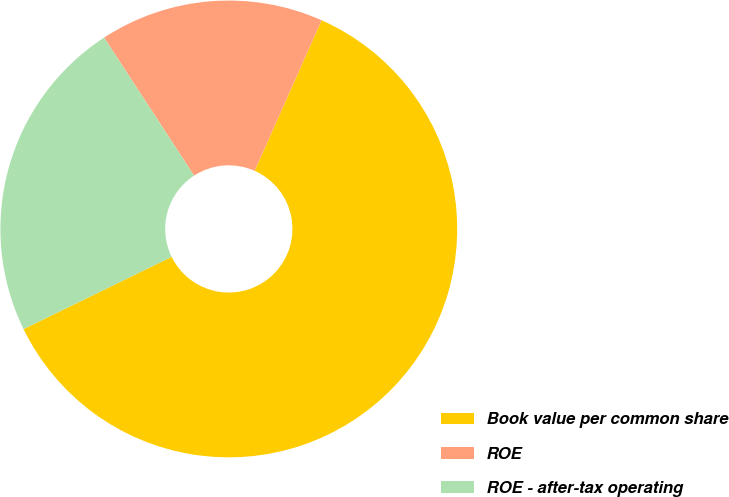Convert chart to OTSL. <chart><loc_0><loc_0><loc_500><loc_500><pie_chart><fcel>Book value per common share<fcel>ROE<fcel>ROE - after-tax operating<nl><fcel>61.12%<fcel>15.85%<fcel>23.03%<nl></chart> 